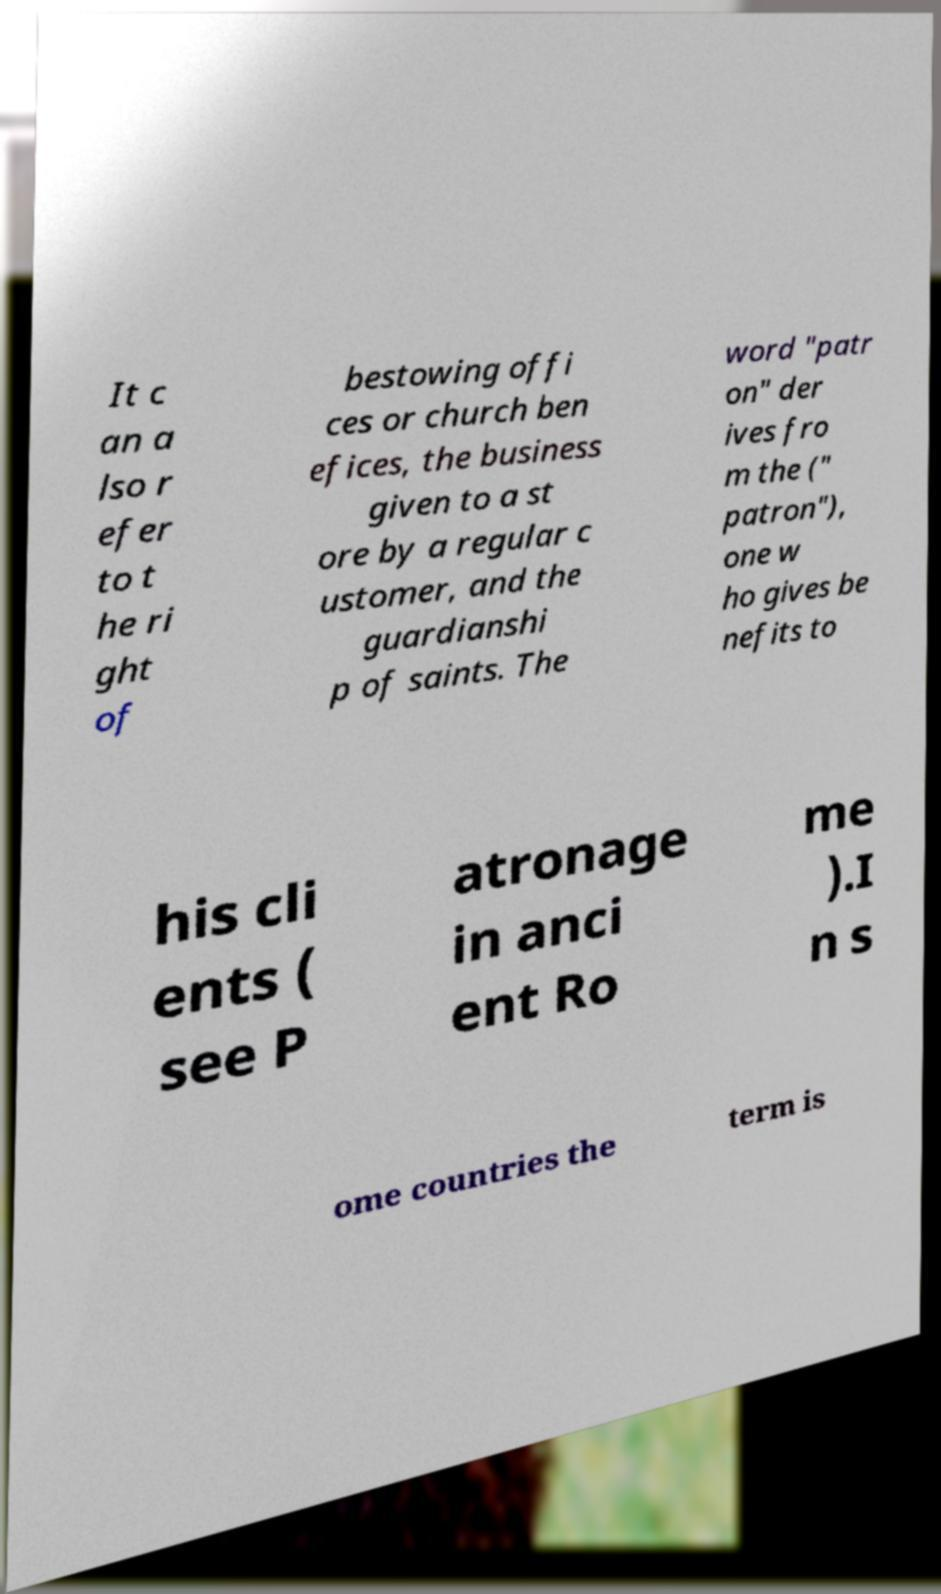Could you extract and type out the text from this image? It c an a lso r efer to t he ri ght of bestowing offi ces or church ben efices, the business given to a st ore by a regular c ustomer, and the guardianshi p of saints. The word "patr on" der ives fro m the (" patron"), one w ho gives be nefits to his cli ents ( see P atronage in anci ent Ro me ).I n s ome countries the term is 